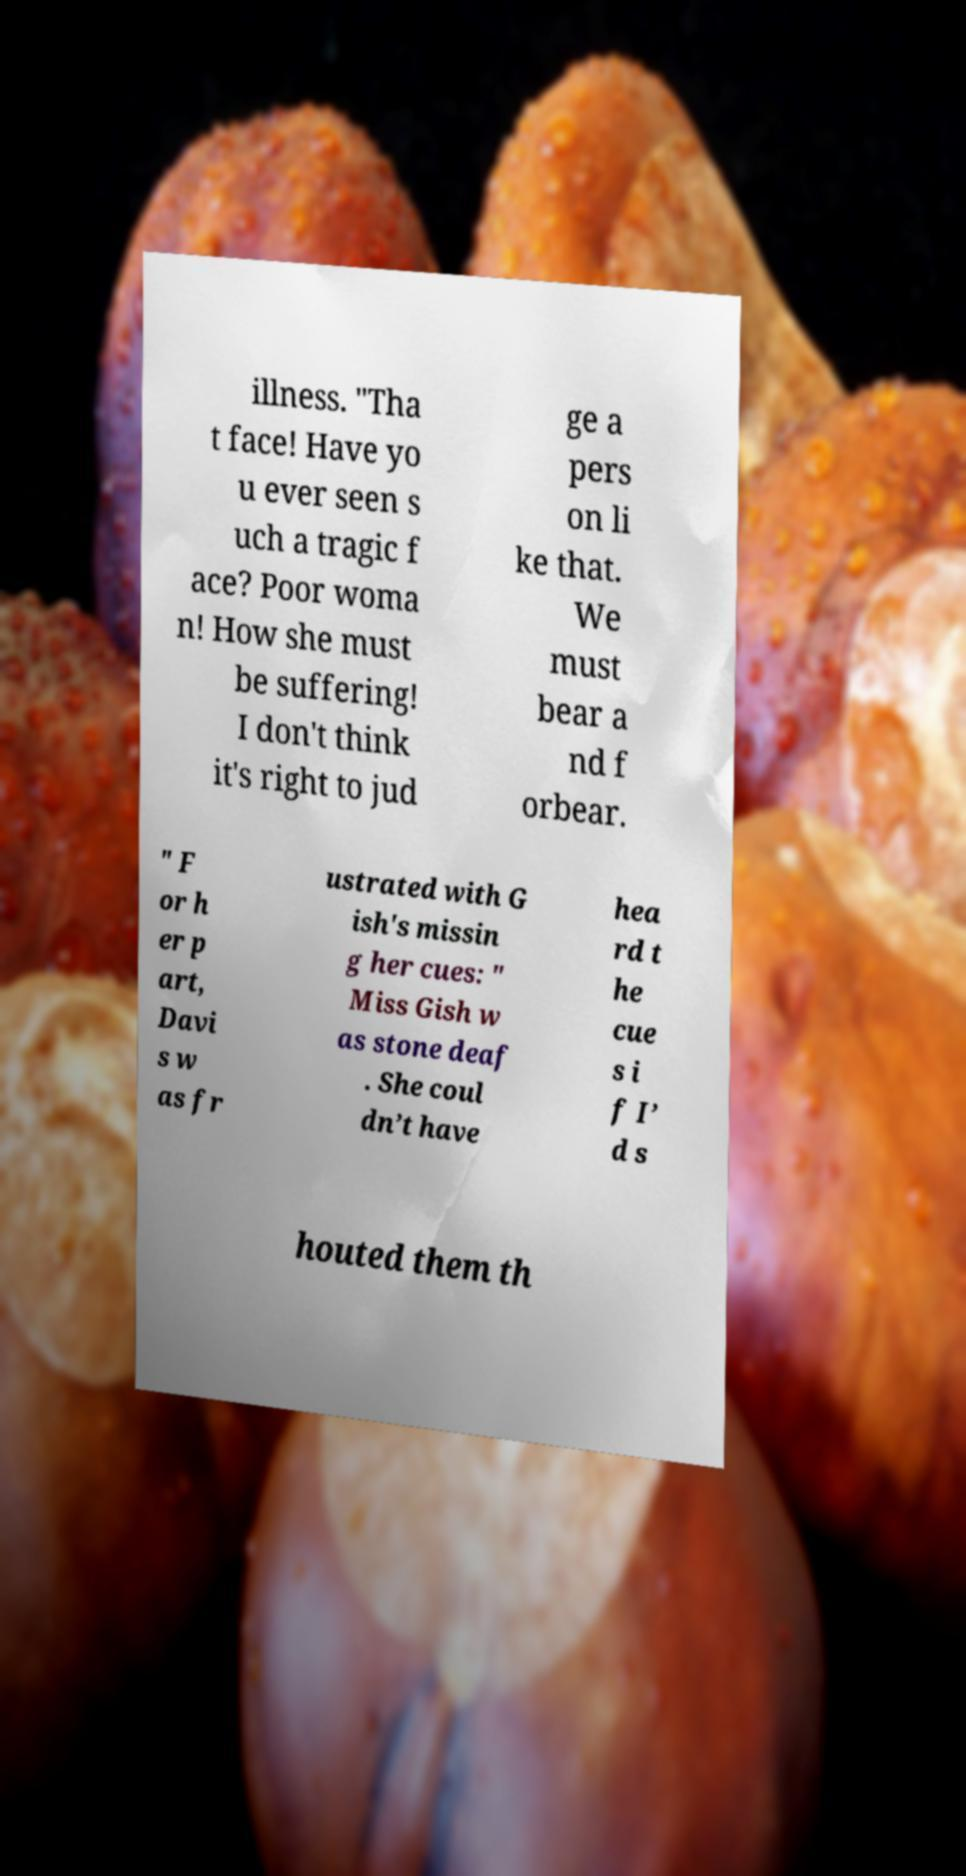Please identify and transcribe the text found in this image. illness. "Tha t face! Have yo u ever seen s uch a tragic f ace? Poor woma n! How she must be suffering! I don't think it's right to jud ge a pers on li ke that. We must bear a nd f orbear. " F or h er p art, Davi s w as fr ustrated with G ish's missin g her cues: " Miss Gish w as stone deaf . She coul dn’t have hea rd t he cue s i f I’ d s houted them th 